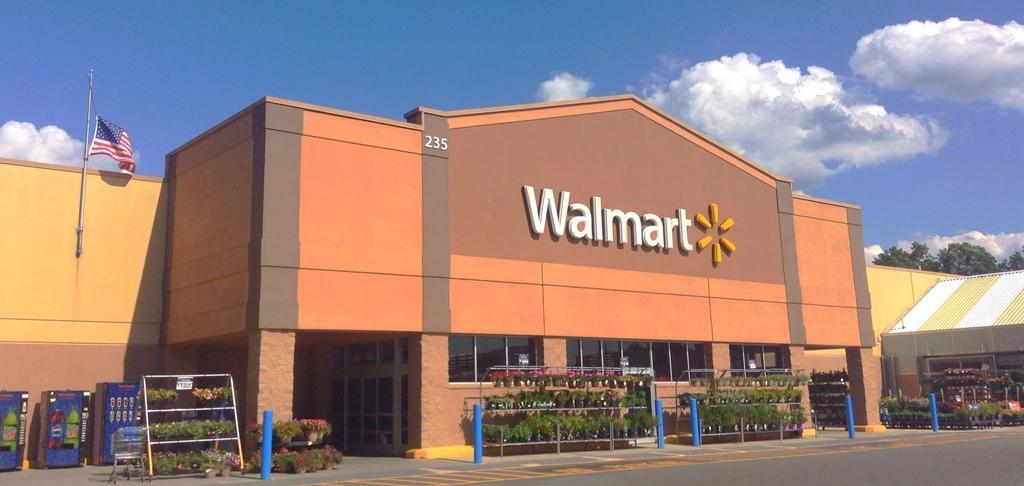Can you describe this image briefly? Here we can see plants, flowers, machines, cart, flag, shade, trees, and a building. Here we can see a road. In the background there is sky with clouds. 